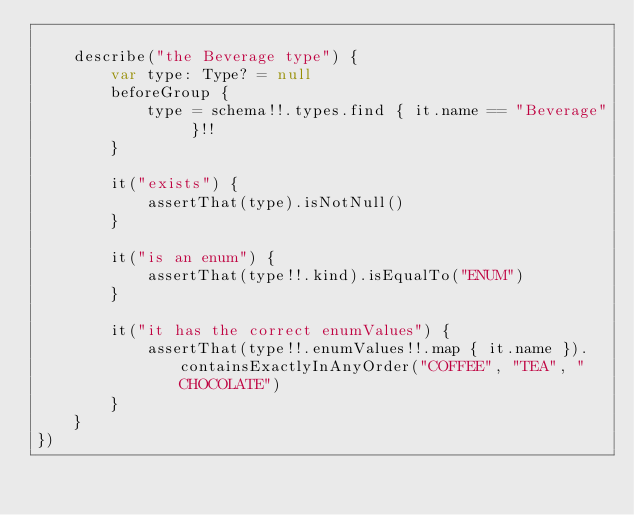Convert code to text. <code><loc_0><loc_0><loc_500><loc_500><_Kotlin_>
    describe("the Beverage type") {
        var type: Type? = null
        beforeGroup {
            type = schema!!.types.find { it.name == "Beverage" }!!
        }

        it("exists") {
            assertThat(type).isNotNull()
        }

        it("is an enum") {
            assertThat(type!!.kind).isEqualTo("ENUM")
        }

        it("it has the correct enumValues") {
            assertThat(type!!.enumValues!!.map { it.name }).containsExactlyInAnyOrder("COFFEE", "TEA", "CHOCOLATE")
        }
    }
})
</code> 